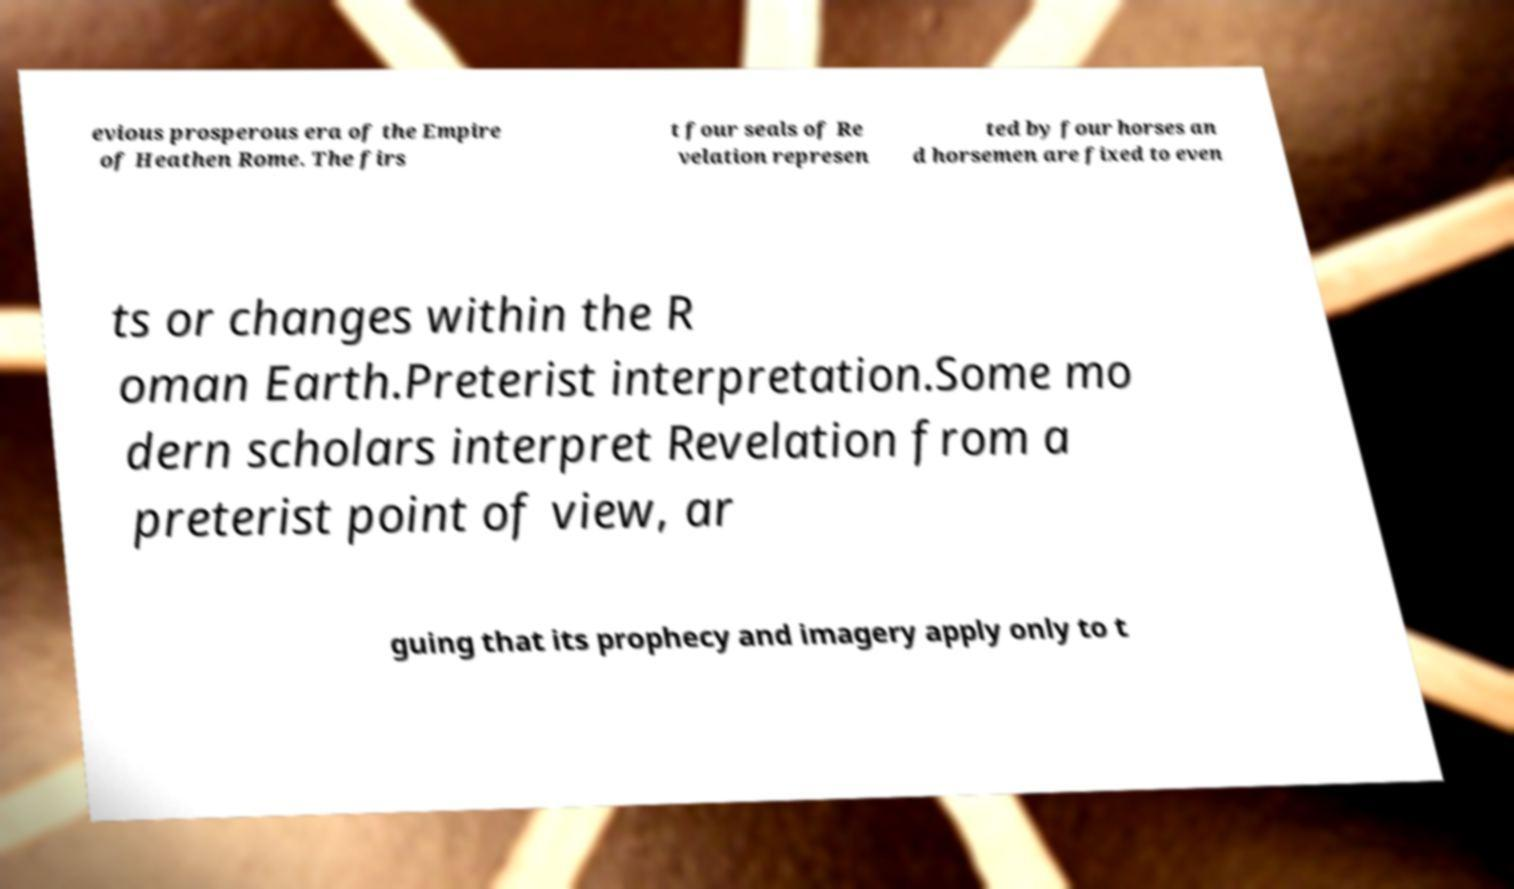Please read and relay the text visible in this image. What does it say? evious prosperous era of the Empire of Heathen Rome. The firs t four seals of Re velation represen ted by four horses an d horsemen are fixed to even ts or changes within the R oman Earth.Preterist interpretation.Some mo dern scholars interpret Revelation from a preterist point of view, ar guing that its prophecy and imagery apply only to t 